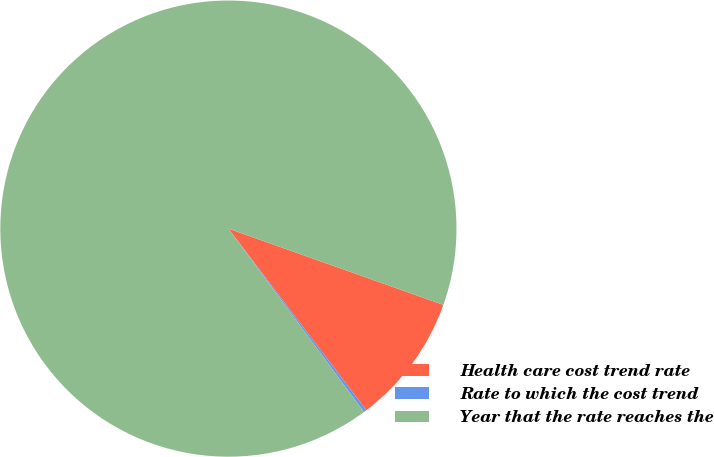Convert chart to OTSL. <chart><loc_0><loc_0><loc_500><loc_500><pie_chart><fcel>Health care cost trend rate<fcel>Rate to which the cost trend<fcel>Year that the rate reaches the<nl><fcel>9.24%<fcel>0.2%<fcel>90.56%<nl></chart> 